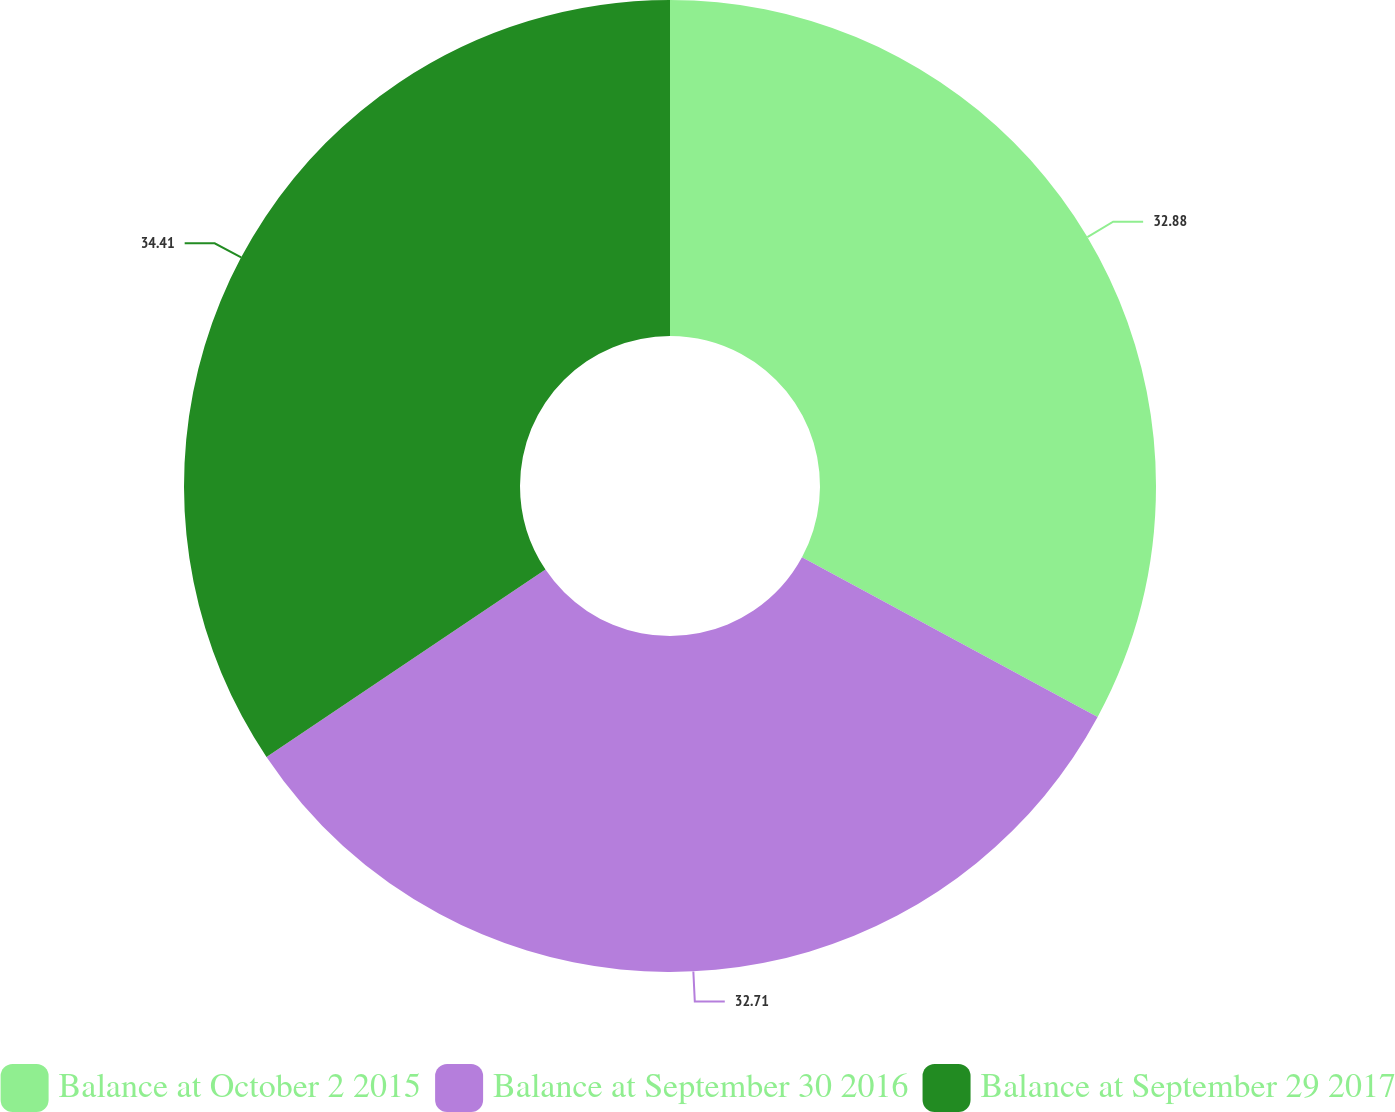Convert chart. <chart><loc_0><loc_0><loc_500><loc_500><pie_chart><fcel>Balance at October 2 2015<fcel>Balance at September 30 2016<fcel>Balance at September 29 2017<nl><fcel>32.88%<fcel>32.71%<fcel>34.41%<nl></chart> 